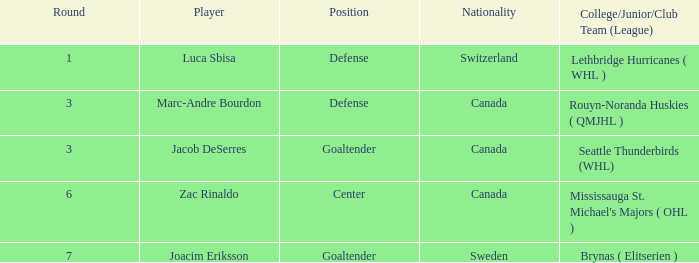What position did Luca Sbisa play for the Philadelphia Flyers? Defense. 